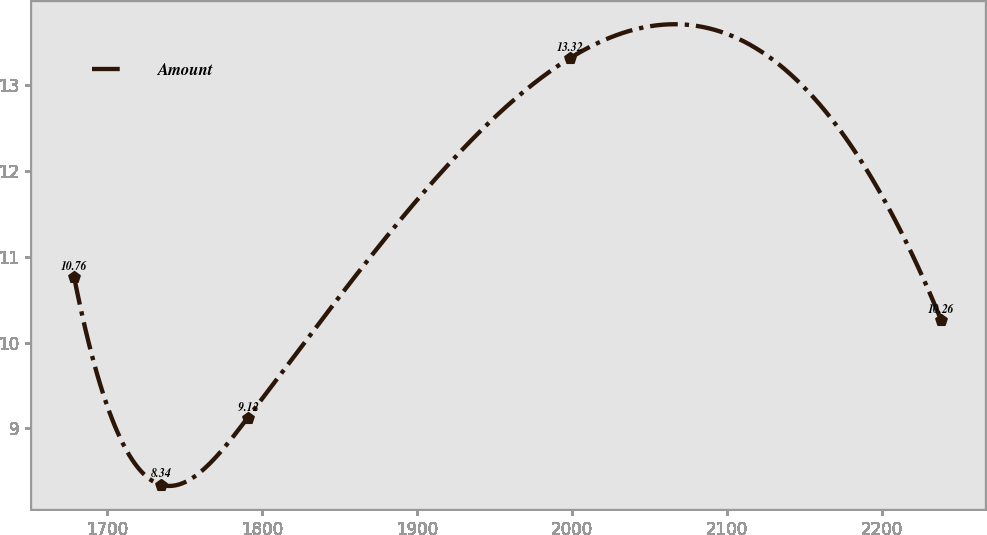Convert chart to OTSL. <chart><loc_0><loc_0><loc_500><loc_500><line_chart><ecel><fcel>Amount<nl><fcel>1678.53<fcel>10.76<nl><fcel>1734.51<fcel>8.34<nl><fcel>1790.49<fcel>9.12<nl><fcel>1998.67<fcel>13.32<nl><fcel>2238.35<fcel>10.26<nl></chart> 